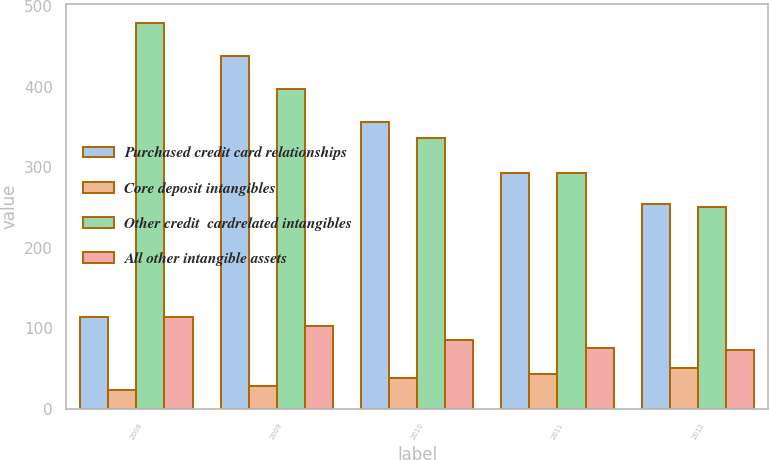<chart> <loc_0><loc_0><loc_500><loc_500><stacked_bar_chart><ecel><fcel>2008<fcel>2009<fcel>2010<fcel>2011<fcel>2012<nl><fcel>Purchased credit card relationships<fcel>114<fcel>438<fcel>356<fcel>293<fcel>254<nl><fcel>Core deposit intangibles<fcel>23<fcel>29<fcel>38<fcel>43<fcel>51<nl><fcel>Other credit  cardrelated intangibles<fcel>479<fcel>397<fcel>336<fcel>293<fcel>251<nl><fcel>All other intangible assets<fcel>114<fcel>103<fcel>86<fcel>76<fcel>73<nl></chart> 